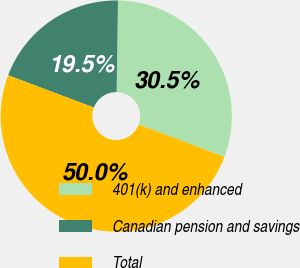Convert chart. <chart><loc_0><loc_0><loc_500><loc_500><pie_chart><fcel>401(k) and enhanced<fcel>Canadian pension and savings<fcel>Total<nl><fcel>30.51%<fcel>19.49%<fcel>50.0%<nl></chart> 